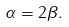<formula> <loc_0><loc_0><loc_500><loc_500>\alpha = 2 \beta .</formula> 